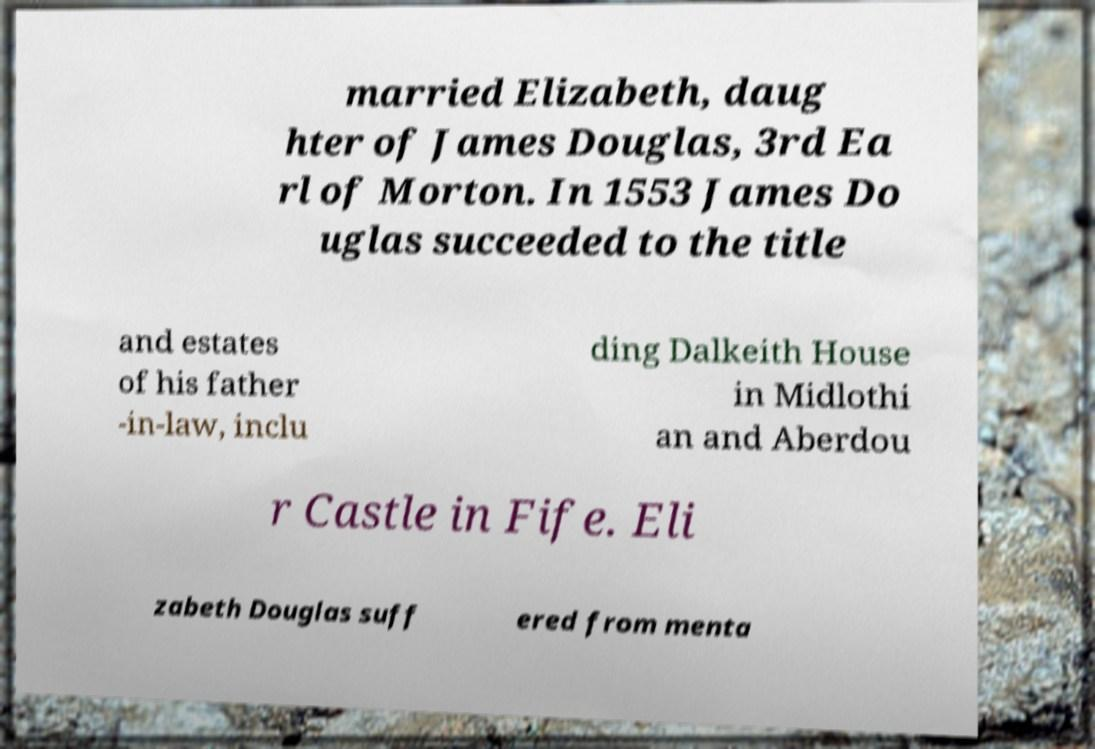Can you read and provide the text displayed in the image?This photo seems to have some interesting text. Can you extract and type it out for me? married Elizabeth, daug hter of James Douglas, 3rd Ea rl of Morton. In 1553 James Do uglas succeeded to the title and estates of his father -in-law, inclu ding Dalkeith House in Midlothi an and Aberdou r Castle in Fife. Eli zabeth Douglas suff ered from menta 